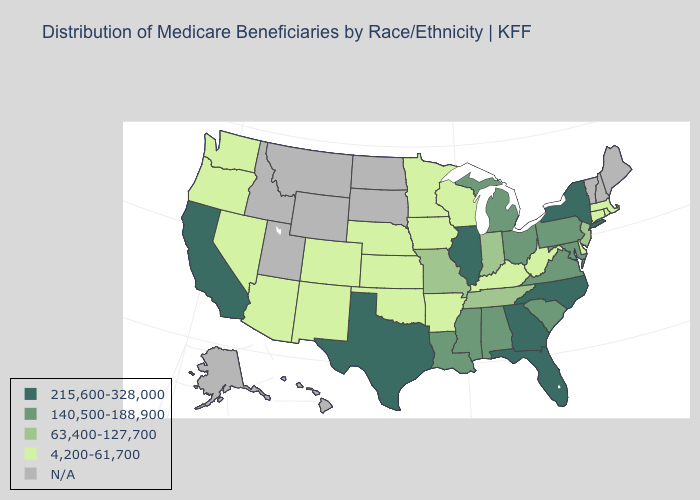Does Georgia have the highest value in the USA?
Quick response, please. Yes. How many symbols are there in the legend?
Quick response, please. 5. What is the highest value in states that border Idaho?
Write a very short answer. 4,200-61,700. Which states have the lowest value in the South?
Answer briefly. Arkansas, Delaware, Kentucky, Oklahoma, West Virginia. How many symbols are there in the legend?
Concise answer only. 5. Among the states that border Louisiana , does Arkansas have the lowest value?
Short answer required. Yes. Does the map have missing data?
Write a very short answer. Yes. Among the states that border Maryland , which have the highest value?
Short answer required. Pennsylvania, Virginia. Name the states that have a value in the range 215,600-328,000?
Be succinct. California, Florida, Georgia, Illinois, New York, North Carolina, Texas. What is the value of Pennsylvania?
Keep it brief. 140,500-188,900. Is the legend a continuous bar?
Concise answer only. No. What is the value of Alaska?
Write a very short answer. N/A. 